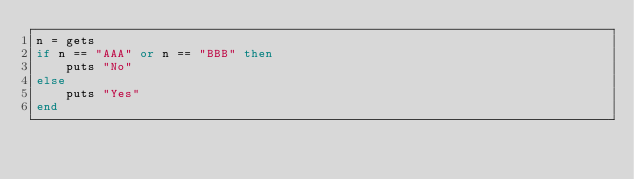<code> <loc_0><loc_0><loc_500><loc_500><_Ruby_>n = gets
if n == "AAA" or n == "BBB" then
    puts "No"
else
    puts "Yes"
end</code> 